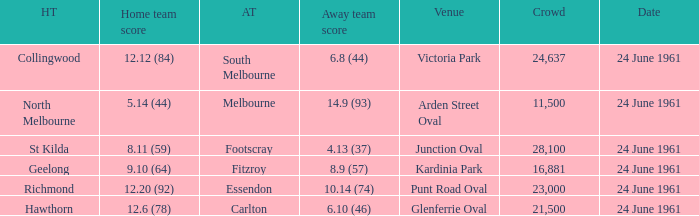What is the date of the game where the home team scored 9.10 (64)? 24 June 1961. 